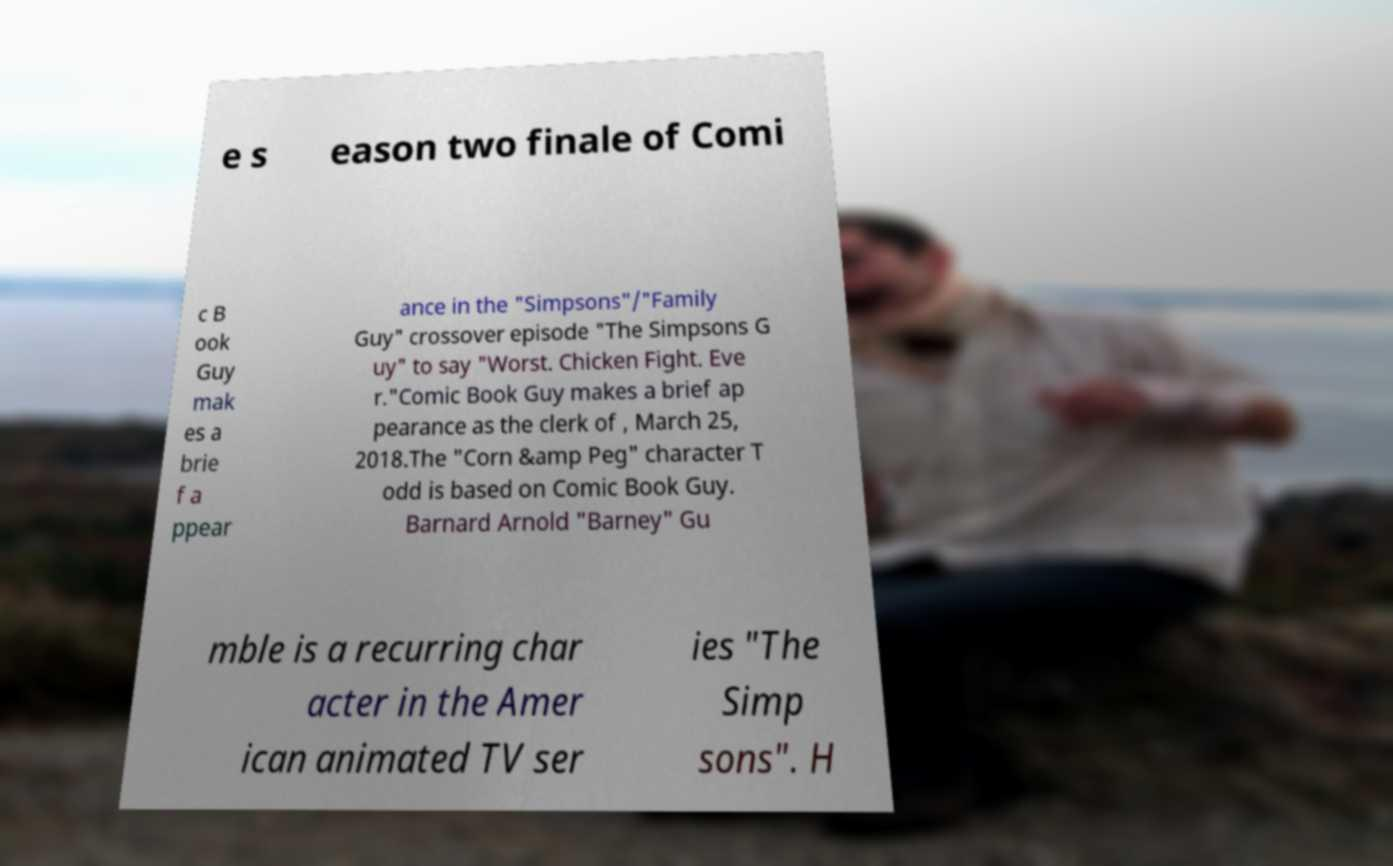Please identify and transcribe the text found in this image. e s eason two finale of Comi c B ook Guy mak es a brie f a ppear ance in the "Simpsons"/"Family Guy" crossover episode "The Simpsons G uy" to say "Worst. Chicken Fight. Eve r."Comic Book Guy makes a brief ap pearance as the clerk of , March 25, 2018.The "Corn &amp Peg" character T odd is based on Comic Book Guy. Barnard Arnold "Barney" Gu mble is a recurring char acter in the Amer ican animated TV ser ies "The Simp sons". H 